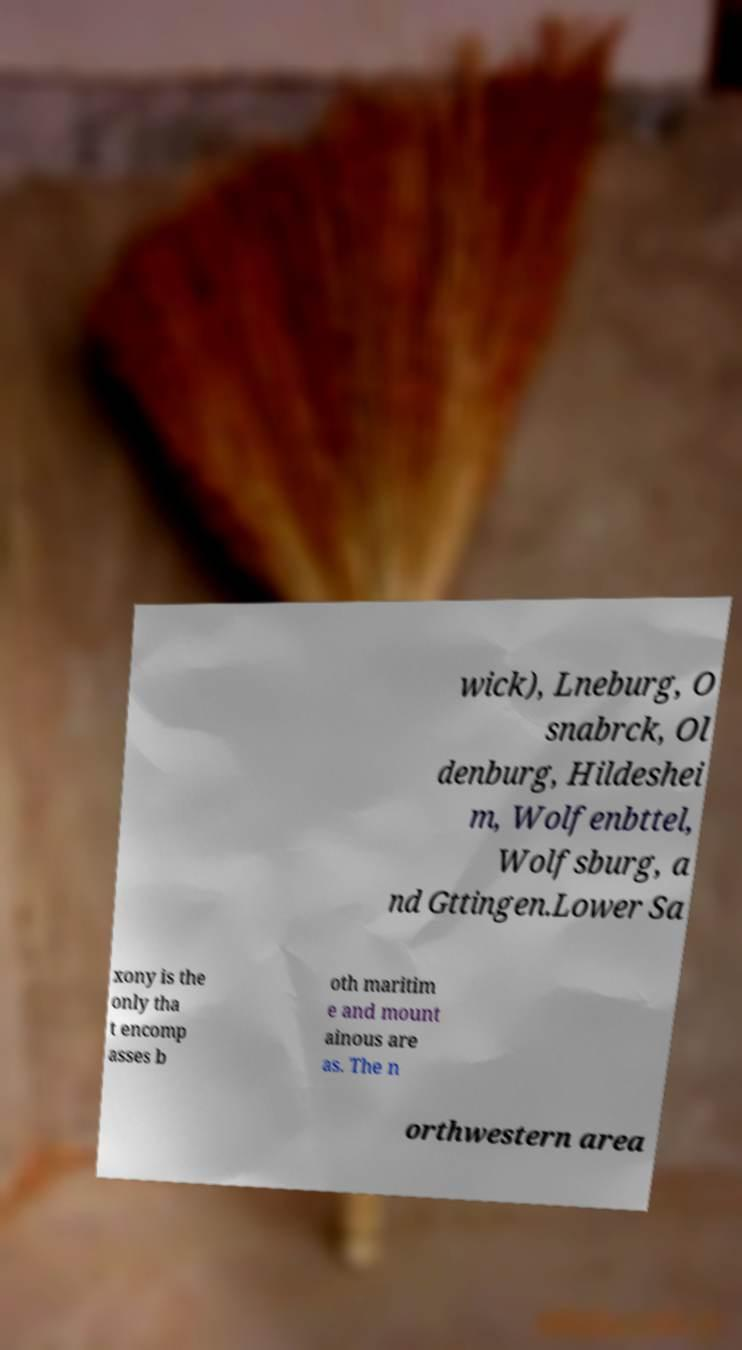Could you extract and type out the text from this image? wick), Lneburg, O snabrck, Ol denburg, Hildeshei m, Wolfenbttel, Wolfsburg, a nd Gttingen.Lower Sa xony is the only tha t encomp asses b oth maritim e and mount ainous are as. The n orthwestern area 